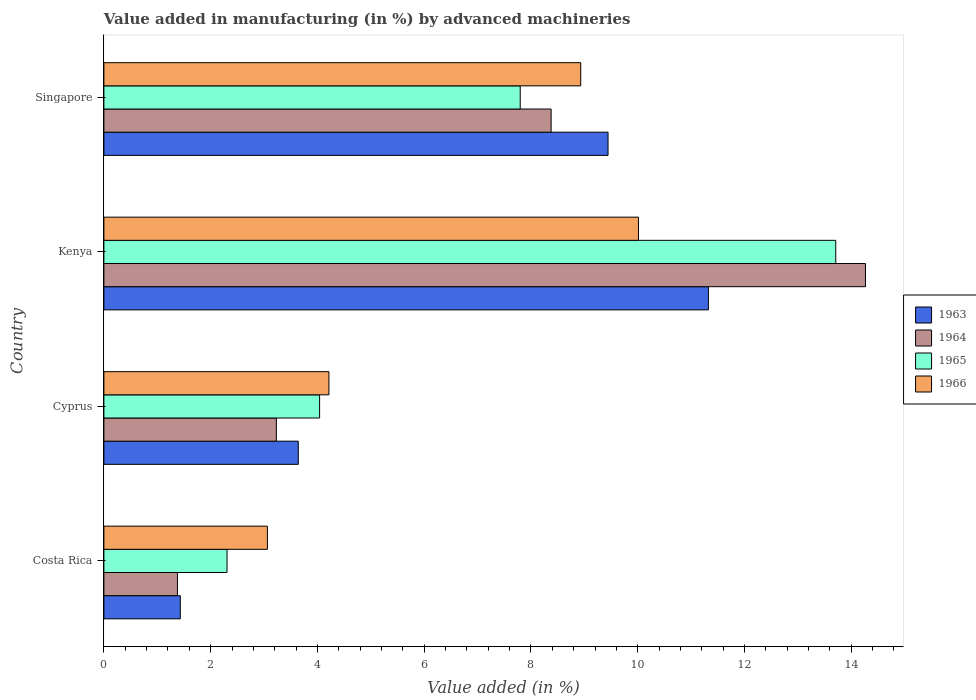How many different coloured bars are there?
Make the answer very short. 4. Are the number of bars on each tick of the Y-axis equal?
Make the answer very short. Yes. How many bars are there on the 4th tick from the bottom?
Ensure brevity in your answer.  4. What is the label of the 1st group of bars from the top?
Keep it short and to the point. Singapore. In how many cases, is the number of bars for a given country not equal to the number of legend labels?
Give a very brief answer. 0. What is the percentage of value added in manufacturing by advanced machineries in 1965 in Costa Rica?
Your answer should be compact. 2.31. Across all countries, what is the maximum percentage of value added in manufacturing by advanced machineries in 1966?
Your answer should be very brief. 10.01. Across all countries, what is the minimum percentage of value added in manufacturing by advanced machineries in 1963?
Keep it short and to the point. 1.43. In which country was the percentage of value added in manufacturing by advanced machineries in 1965 maximum?
Your answer should be very brief. Kenya. What is the total percentage of value added in manufacturing by advanced machineries in 1964 in the graph?
Provide a short and direct response. 27.25. What is the difference between the percentage of value added in manufacturing by advanced machineries in 1963 in Costa Rica and that in Cyprus?
Keep it short and to the point. -2.21. What is the difference between the percentage of value added in manufacturing by advanced machineries in 1963 in Kenya and the percentage of value added in manufacturing by advanced machineries in 1965 in Singapore?
Make the answer very short. 3.52. What is the average percentage of value added in manufacturing by advanced machineries in 1966 per country?
Your answer should be very brief. 6.56. What is the difference between the percentage of value added in manufacturing by advanced machineries in 1963 and percentage of value added in manufacturing by advanced machineries in 1966 in Cyprus?
Make the answer very short. -0.57. In how many countries, is the percentage of value added in manufacturing by advanced machineries in 1963 greater than 4.4 %?
Offer a terse response. 2. What is the ratio of the percentage of value added in manufacturing by advanced machineries in 1965 in Kenya to that in Singapore?
Give a very brief answer. 1.76. Is the percentage of value added in manufacturing by advanced machineries in 1963 in Cyprus less than that in Singapore?
Give a very brief answer. Yes. What is the difference between the highest and the second highest percentage of value added in manufacturing by advanced machineries in 1964?
Make the answer very short. 5.89. What is the difference between the highest and the lowest percentage of value added in manufacturing by advanced machineries in 1964?
Make the answer very short. 12.89. What does the 2nd bar from the bottom in Singapore represents?
Keep it short and to the point. 1964. How many bars are there?
Your response must be concise. 16. What is the difference between two consecutive major ticks on the X-axis?
Offer a terse response. 2. Where does the legend appear in the graph?
Make the answer very short. Center right. How are the legend labels stacked?
Keep it short and to the point. Vertical. What is the title of the graph?
Provide a succinct answer. Value added in manufacturing (in %) by advanced machineries. What is the label or title of the X-axis?
Ensure brevity in your answer.  Value added (in %). What is the label or title of the Y-axis?
Keep it short and to the point. Country. What is the Value added (in %) of 1963 in Costa Rica?
Provide a short and direct response. 1.43. What is the Value added (in %) in 1964 in Costa Rica?
Offer a very short reply. 1.38. What is the Value added (in %) of 1965 in Costa Rica?
Make the answer very short. 2.31. What is the Value added (in %) in 1966 in Costa Rica?
Ensure brevity in your answer.  3.06. What is the Value added (in %) in 1963 in Cyprus?
Make the answer very short. 3.64. What is the Value added (in %) in 1964 in Cyprus?
Keep it short and to the point. 3.23. What is the Value added (in %) of 1965 in Cyprus?
Provide a succinct answer. 4.04. What is the Value added (in %) in 1966 in Cyprus?
Provide a short and direct response. 4.22. What is the Value added (in %) in 1963 in Kenya?
Provide a succinct answer. 11.32. What is the Value added (in %) of 1964 in Kenya?
Provide a succinct answer. 14.27. What is the Value added (in %) of 1965 in Kenya?
Ensure brevity in your answer.  13.71. What is the Value added (in %) of 1966 in Kenya?
Your answer should be compact. 10.01. What is the Value added (in %) of 1963 in Singapore?
Ensure brevity in your answer.  9.44. What is the Value added (in %) in 1964 in Singapore?
Offer a terse response. 8.38. What is the Value added (in %) in 1965 in Singapore?
Keep it short and to the point. 7.8. What is the Value added (in %) of 1966 in Singapore?
Ensure brevity in your answer.  8.93. Across all countries, what is the maximum Value added (in %) in 1963?
Your answer should be very brief. 11.32. Across all countries, what is the maximum Value added (in %) of 1964?
Offer a very short reply. 14.27. Across all countries, what is the maximum Value added (in %) in 1965?
Your answer should be compact. 13.71. Across all countries, what is the maximum Value added (in %) in 1966?
Your answer should be compact. 10.01. Across all countries, what is the minimum Value added (in %) in 1963?
Ensure brevity in your answer.  1.43. Across all countries, what is the minimum Value added (in %) of 1964?
Your answer should be compact. 1.38. Across all countries, what is the minimum Value added (in %) in 1965?
Keep it short and to the point. 2.31. Across all countries, what is the minimum Value added (in %) in 1966?
Your response must be concise. 3.06. What is the total Value added (in %) in 1963 in the graph?
Provide a succinct answer. 25.84. What is the total Value added (in %) of 1964 in the graph?
Your answer should be very brief. 27.25. What is the total Value added (in %) of 1965 in the graph?
Your answer should be very brief. 27.86. What is the total Value added (in %) in 1966 in the graph?
Provide a succinct answer. 26.23. What is the difference between the Value added (in %) in 1963 in Costa Rica and that in Cyprus?
Provide a succinct answer. -2.21. What is the difference between the Value added (in %) in 1964 in Costa Rica and that in Cyprus?
Provide a succinct answer. -1.85. What is the difference between the Value added (in %) of 1965 in Costa Rica and that in Cyprus?
Your answer should be very brief. -1.73. What is the difference between the Value added (in %) in 1966 in Costa Rica and that in Cyprus?
Keep it short and to the point. -1.15. What is the difference between the Value added (in %) in 1963 in Costa Rica and that in Kenya?
Ensure brevity in your answer.  -9.89. What is the difference between the Value added (in %) of 1964 in Costa Rica and that in Kenya?
Offer a terse response. -12.89. What is the difference between the Value added (in %) of 1965 in Costa Rica and that in Kenya?
Your answer should be compact. -11.4. What is the difference between the Value added (in %) in 1966 in Costa Rica and that in Kenya?
Provide a short and direct response. -6.95. What is the difference between the Value added (in %) of 1963 in Costa Rica and that in Singapore?
Your response must be concise. -8.01. What is the difference between the Value added (in %) of 1964 in Costa Rica and that in Singapore?
Give a very brief answer. -7. What is the difference between the Value added (in %) in 1965 in Costa Rica and that in Singapore?
Your response must be concise. -5.49. What is the difference between the Value added (in %) of 1966 in Costa Rica and that in Singapore?
Your response must be concise. -5.87. What is the difference between the Value added (in %) of 1963 in Cyprus and that in Kenya?
Provide a succinct answer. -7.68. What is the difference between the Value added (in %) in 1964 in Cyprus and that in Kenya?
Provide a short and direct response. -11.04. What is the difference between the Value added (in %) in 1965 in Cyprus and that in Kenya?
Offer a very short reply. -9.67. What is the difference between the Value added (in %) of 1966 in Cyprus and that in Kenya?
Give a very brief answer. -5.8. What is the difference between the Value added (in %) of 1963 in Cyprus and that in Singapore?
Give a very brief answer. -5.8. What is the difference between the Value added (in %) in 1964 in Cyprus and that in Singapore?
Offer a very short reply. -5.15. What is the difference between the Value added (in %) in 1965 in Cyprus and that in Singapore?
Provide a succinct answer. -3.76. What is the difference between the Value added (in %) in 1966 in Cyprus and that in Singapore?
Provide a succinct answer. -4.72. What is the difference between the Value added (in %) of 1963 in Kenya and that in Singapore?
Offer a very short reply. 1.88. What is the difference between the Value added (in %) of 1964 in Kenya and that in Singapore?
Your answer should be compact. 5.89. What is the difference between the Value added (in %) in 1965 in Kenya and that in Singapore?
Make the answer very short. 5.91. What is the difference between the Value added (in %) of 1966 in Kenya and that in Singapore?
Provide a short and direct response. 1.08. What is the difference between the Value added (in %) in 1963 in Costa Rica and the Value added (in %) in 1964 in Cyprus?
Provide a succinct answer. -1.8. What is the difference between the Value added (in %) of 1963 in Costa Rica and the Value added (in %) of 1965 in Cyprus?
Provide a short and direct response. -2.61. What is the difference between the Value added (in %) in 1963 in Costa Rica and the Value added (in %) in 1966 in Cyprus?
Your answer should be very brief. -2.78. What is the difference between the Value added (in %) in 1964 in Costa Rica and the Value added (in %) in 1965 in Cyprus?
Offer a very short reply. -2.66. What is the difference between the Value added (in %) in 1964 in Costa Rica and the Value added (in %) in 1966 in Cyprus?
Keep it short and to the point. -2.84. What is the difference between the Value added (in %) in 1965 in Costa Rica and the Value added (in %) in 1966 in Cyprus?
Offer a terse response. -1.91. What is the difference between the Value added (in %) of 1963 in Costa Rica and the Value added (in %) of 1964 in Kenya?
Ensure brevity in your answer.  -12.84. What is the difference between the Value added (in %) of 1963 in Costa Rica and the Value added (in %) of 1965 in Kenya?
Your answer should be compact. -12.28. What is the difference between the Value added (in %) in 1963 in Costa Rica and the Value added (in %) in 1966 in Kenya?
Offer a very short reply. -8.58. What is the difference between the Value added (in %) in 1964 in Costa Rica and the Value added (in %) in 1965 in Kenya?
Your response must be concise. -12.33. What is the difference between the Value added (in %) in 1964 in Costa Rica and the Value added (in %) in 1966 in Kenya?
Your answer should be compact. -8.64. What is the difference between the Value added (in %) in 1965 in Costa Rica and the Value added (in %) in 1966 in Kenya?
Ensure brevity in your answer.  -7.71. What is the difference between the Value added (in %) of 1963 in Costa Rica and the Value added (in %) of 1964 in Singapore?
Your answer should be compact. -6.95. What is the difference between the Value added (in %) in 1963 in Costa Rica and the Value added (in %) in 1965 in Singapore?
Offer a very short reply. -6.37. What is the difference between the Value added (in %) of 1963 in Costa Rica and the Value added (in %) of 1966 in Singapore?
Your response must be concise. -7.5. What is the difference between the Value added (in %) in 1964 in Costa Rica and the Value added (in %) in 1965 in Singapore?
Give a very brief answer. -6.42. What is the difference between the Value added (in %) in 1964 in Costa Rica and the Value added (in %) in 1966 in Singapore?
Provide a short and direct response. -7.55. What is the difference between the Value added (in %) of 1965 in Costa Rica and the Value added (in %) of 1966 in Singapore?
Your response must be concise. -6.63. What is the difference between the Value added (in %) of 1963 in Cyprus and the Value added (in %) of 1964 in Kenya?
Provide a succinct answer. -10.63. What is the difference between the Value added (in %) in 1963 in Cyprus and the Value added (in %) in 1965 in Kenya?
Offer a very short reply. -10.07. What is the difference between the Value added (in %) in 1963 in Cyprus and the Value added (in %) in 1966 in Kenya?
Give a very brief answer. -6.37. What is the difference between the Value added (in %) in 1964 in Cyprus and the Value added (in %) in 1965 in Kenya?
Offer a terse response. -10.48. What is the difference between the Value added (in %) of 1964 in Cyprus and the Value added (in %) of 1966 in Kenya?
Offer a terse response. -6.78. What is the difference between the Value added (in %) of 1965 in Cyprus and the Value added (in %) of 1966 in Kenya?
Your response must be concise. -5.97. What is the difference between the Value added (in %) of 1963 in Cyprus and the Value added (in %) of 1964 in Singapore?
Make the answer very short. -4.74. What is the difference between the Value added (in %) of 1963 in Cyprus and the Value added (in %) of 1965 in Singapore?
Your answer should be compact. -4.16. What is the difference between the Value added (in %) in 1963 in Cyprus and the Value added (in %) in 1966 in Singapore?
Provide a succinct answer. -5.29. What is the difference between the Value added (in %) of 1964 in Cyprus and the Value added (in %) of 1965 in Singapore?
Your answer should be compact. -4.57. What is the difference between the Value added (in %) in 1964 in Cyprus and the Value added (in %) in 1966 in Singapore?
Give a very brief answer. -5.7. What is the difference between the Value added (in %) in 1965 in Cyprus and the Value added (in %) in 1966 in Singapore?
Provide a short and direct response. -4.89. What is the difference between the Value added (in %) in 1963 in Kenya and the Value added (in %) in 1964 in Singapore?
Give a very brief answer. 2.95. What is the difference between the Value added (in %) in 1963 in Kenya and the Value added (in %) in 1965 in Singapore?
Give a very brief answer. 3.52. What is the difference between the Value added (in %) in 1963 in Kenya and the Value added (in %) in 1966 in Singapore?
Ensure brevity in your answer.  2.39. What is the difference between the Value added (in %) of 1964 in Kenya and the Value added (in %) of 1965 in Singapore?
Your answer should be very brief. 6.47. What is the difference between the Value added (in %) of 1964 in Kenya and the Value added (in %) of 1966 in Singapore?
Keep it short and to the point. 5.33. What is the difference between the Value added (in %) of 1965 in Kenya and the Value added (in %) of 1966 in Singapore?
Your response must be concise. 4.78. What is the average Value added (in %) in 1963 per country?
Offer a terse response. 6.46. What is the average Value added (in %) of 1964 per country?
Offer a terse response. 6.81. What is the average Value added (in %) in 1965 per country?
Ensure brevity in your answer.  6.96. What is the average Value added (in %) of 1966 per country?
Provide a short and direct response. 6.56. What is the difference between the Value added (in %) of 1963 and Value added (in %) of 1964 in Costa Rica?
Your response must be concise. 0.05. What is the difference between the Value added (in %) in 1963 and Value added (in %) in 1965 in Costa Rica?
Offer a terse response. -0.88. What is the difference between the Value added (in %) of 1963 and Value added (in %) of 1966 in Costa Rica?
Make the answer very short. -1.63. What is the difference between the Value added (in %) in 1964 and Value added (in %) in 1965 in Costa Rica?
Give a very brief answer. -0.93. What is the difference between the Value added (in %) in 1964 and Value added (in %) in 1966 in Costa Rica?
Provide a succinct answer. -1.69. What is the difference between the Value added (in %) of 1965 and Value added (in %) of 1966 in Costa Rica?
Your answer should be compact. -0.76. What is the difference between the Value added (in %) of 1963 and Value added (in %) of 1964 in Cyprus?
Keep it short and to the point. 0.41. What is the difference between the Value added (in %) of 1963 and Value added (in %) of 1965 in Cyprus?
Offer a terse response. -0.4. What is the difference between the Value added (in %) in 1963 and Value added (in %) in 1966 in Cyprus?
Ensure brevity in your answer.  -0.57. What is the difference between the Value added (in %) of 1964 and Value added (in %) of 1965 in Cyprus?
Offer a very short reply. -0.81. What is the difference between the Value added (in %) in 1964 and Value added (in %) in 1966 in Cyprus?
Offer a very short reply. -0.98. What is the difference between the Value added (in %) in 1965 and Value added (in %) in 1966 in Cyprus?
Offer a terse response. -0.17. What is the difference between the Value added (in %) of 1963 and Value added (in %) of 1964 in Kenya?
Make the answer very short. -2.94. What is the difference between the Value added (in %) in 1963 and Value added (in %) in 1965 in Kenya?
Offer a terse response. -2.39. What is the difference between the Value added (in %) in 1963 and Value added (in %) in 1966 in Kenya?
Offer a very short reply. 1.31. What is the difference between the Value added (in %) in 1964 and Value added (in %) in 1965 in Kenya?
Offer a terse response. 0.56. What is the difference between the Value added (in %) in 1964 and Value added (in %) in 1966 in Kenya?
Ensure brevity in your answer.  4.25. What is the difference between the Value added (in %) in 1965 and Value added (in %) in 1966 in Kenya?
Provide a short and direct response. 3.7. What is the difference between the Value added (in %) of 1963 and Value added (in %) of 1964 in Singapore?
Offer a very short reply. 1.07. What is the difference between the Value added (in %) in 1963 and Value added (in %) in 1965 in Singapore?
Your answer should be very brief. 1.64. What is the difference between the Value added (in %) of 1963 and Value added (in %) of 1966 in Singapore?
Provide a succinct answer. 0.51. What is the difference between the Value added (in %) of 1964 and Value added (in %) of 1965 in Singapore?
Your answer should be compact. 0.58. What is the difference between the Value added (in %) of 1964 and Value added (in %) of 1966 in Singapore?
Provide a short and direct response. -0.55. What is the difference between the Value added (in %) in 1965 and Value added (in %) in 1966 in Singapore?
Offer a very short reply. -1.13. What is the ratio of the Value added (in %) in 1963 in Costa Rica to that in Cyprus?
Keep it short and to the point. 0.39. What is the ratio of the Value added (in %) in 1964 in Costa Rica to that in Cyprus?
Give a very brief answer. 0.43. What is the ratio of the Value added (in %) of 1965 in Costa Rica to that in Cyprus?
Make the answer very short. 0.57. What is the ratio of the Value added (in %) in 1966 in Costa Rica to that in Cyprus?
Keep it short and to the point. 0.73. What is the ratio of the Value added (in %) of 1963 in Costa Rica to that in Kenya?
Provide a succinct answer. 0.13. What is the ratio of the Value added (in %) of 1964 in Costa Rica to that in Kenya?
Your answer should be compact. 0.1. What is the ratio of the Value added (in %) in 1965 in Costa Rica to that in Kenya?
Give a very brief answer. 0.17. What is the ratio of the Value added (in %) in 1966 in Costa Rica to that in Kenya?
Provide a succinct answer. 0.31. What is the ratio of the Value added (in %) in 1963 in Costa Rica to that in Singapore?
Provide a succinct answer. 0.15. What is the ratio of the Value added (in %) of 1964 in Costa Rica to that in Singapore?
Provide a short and direct response. 0.16. What is the ratio of the Value added (in %) of 1965 in Costa Rica to that in Singapore?
Give a very brief answer. 0.3. What is the ratio of the Value added (in %) of 1966 in Costa Rica to that in Singapore?
Offer a very short reply. 0.34. What is the ratio of the Value added (in %) in 1963 in Cyprus to that in Kenya?
Make the answer very short. 0.32. What is the ratio of the Value added (in %) in 1964 in Cyprus to that in Kenya?
Keep it short and to the point. 0.23. What is the ratio of the Value added (in %) of 1965 in Cyprus to that in Kenya?
Offer a terse response. 0.29. What is the ratio of the Value added (in %) in 1966 in Cyprus to that in Kenya?
Provide a succinct answer. 0.42. What is the ratio of the Value added (in %) of 1963 in Cyprus to that in Singapore?
Ensure brevity in your answer.  0.39. What is the ratio of the Value added (in %) of 1964 in Cyprus to that in Singapore?
Ensure brevity in your answer.  0.39. What is the ratio of the Value added (in %) in 1965 in Cyprus to that in Singapore?
Provide a succinct answer. 0.52. What is the ratio of the Value added (in %) of 1966 in Cyprus to that in Singapore?
Provide a short and direct response. 0.47. What is the ratio of the Value added (in %) in 1963 in Kenya to that in Singapore?
Keep it short and to the point. 1.2. What is the ratio of the Value added (in %) in 1964 in Kenya to that in Singapore?
Provide a short and direct response. 1.7. What is the ratio of the Value added (in %) of 1965 in Kenya to that in Singapore?
Keep it short and to the point. 1.76. What is the ratio of the Value added (in %) of 1966 in Kenya to that in Singapore?
Provide a succinct answer. 1.12. What is the difference between the highest and the second highest Value added (in %) in 1963?
Provide a succinct answer. 1.88. What is the difference between the highest and the second highest Value added (in %) in 1964?
Offer a very short reply. 5.89. What is the difference between the highest and the second highest Value added (in %) of 1965?
Provide a succinct answer. 5.91. What is the difference between the highest and the second highest Value added (in %) of 1966?
Provide a short and direct response. 1.08. What is the difference between the highest and the lowest Value added (in %) of 1963?
Give a very brief answer. 9.89. What is the difference between the highest and the lowest Value added (in %) of 1964?
Make the answer very short. 12.89. What is the difference between the highest and the lowest Value added (in %) in 1965?
Offer a terse response. 11.4. What is the difference between the highest and the lowest Value added (in %) of 1966?
Make the answer very short. 6.95. 